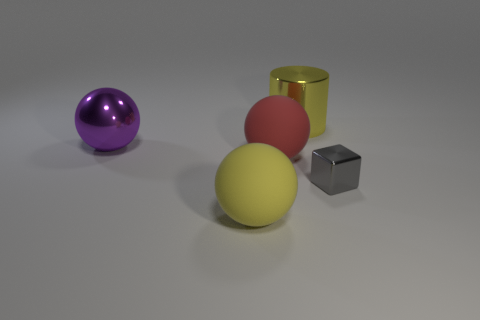What might be the texture of the purple sphere? The texture of the purple sphere looks smooth and glossy, reflecting light uniformly across its surface, which is indicative of a polished finish. Could the material be plastic or something else? It's possible the purple sphere is made of plastic given its smooth appearance, but it could also be a reflective ceramic or even glass. Without more specific information or context, it's difficult to determine the exact material just from the image. 